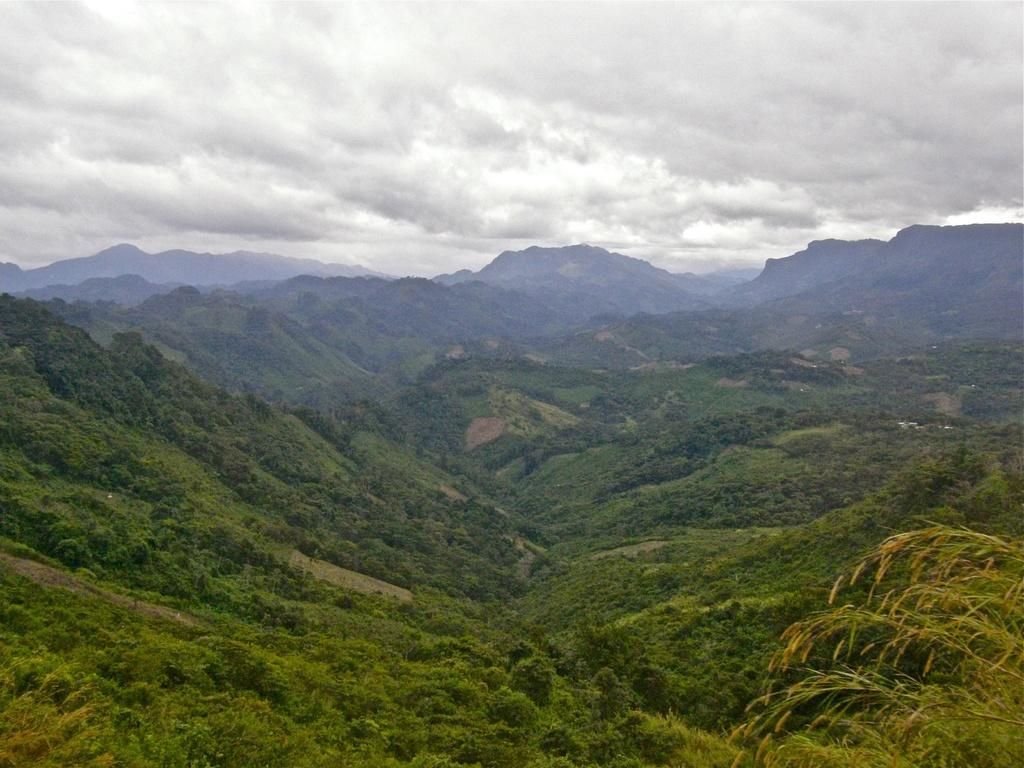Can you describe this image briefly? In this image there are mountains. There are plants and trees on the mountain. At the top there is the sky. 